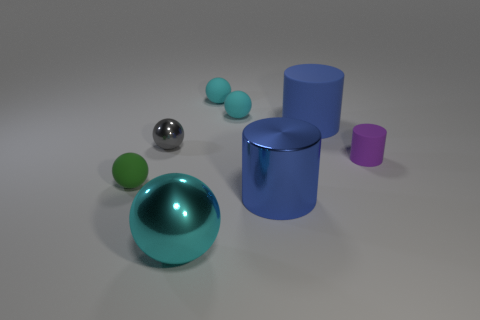The purple rubber object has what size?
Offer a very short reply. Small. What number of objects are either spheres or tiny purple metallic balls?
Provide a succinct answer. 5. There is a cyan ball that is in front of the green ball; what is its size?
Make the answer very short. Large. Is there anything else that has the same size as the cyan shiny object?
Your answer should be very brief. Yes. The tiny matte thing that is both in front of the big blue matte cylinder and on the left side of the blue metallic object is what color?
Your answer should be very brief. Green. Does the large blue thing behind the small purple matte cylinder have the same material as the tiny purple thing?
Ensure brevity in your answer.  Yes. Is the color of the large matte cylinder the same as the big metallic thing behind the big cyan sphere?
Your response must be concise. Yes. There is a small metallic thing; are there any green objects to the left of it?
Provide a succinct answer. Yes. There is a object on the right side of the blue rubber thing; is it the same size as the cylinder that is in front of the small purple thing?
Your answer should be very brief. No. Is there a cyan rubber object of the same size as the gray metal sphere?
Keep it short and to the point. Yes. 